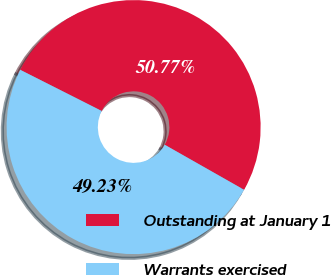Convert chart. <chart><loc_0><loc_0><loc_500><loc_500><pie_chart><fcel>Outstanding at January 1<fcel>Warrants exercised<nl><fcel>50.77%<fcel>49.23%<nl></chart> 